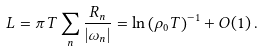<formula> <loc_0><loc_0><loc_500><loc_500>L = \pi T \sum _ { n } \frac { R _ { n } } { | \omega _ { n } | } = \ln \left ( \rho _ { 0 } T \right ) ^ { - 1 } + O ( 1 ) \, .</formula> 